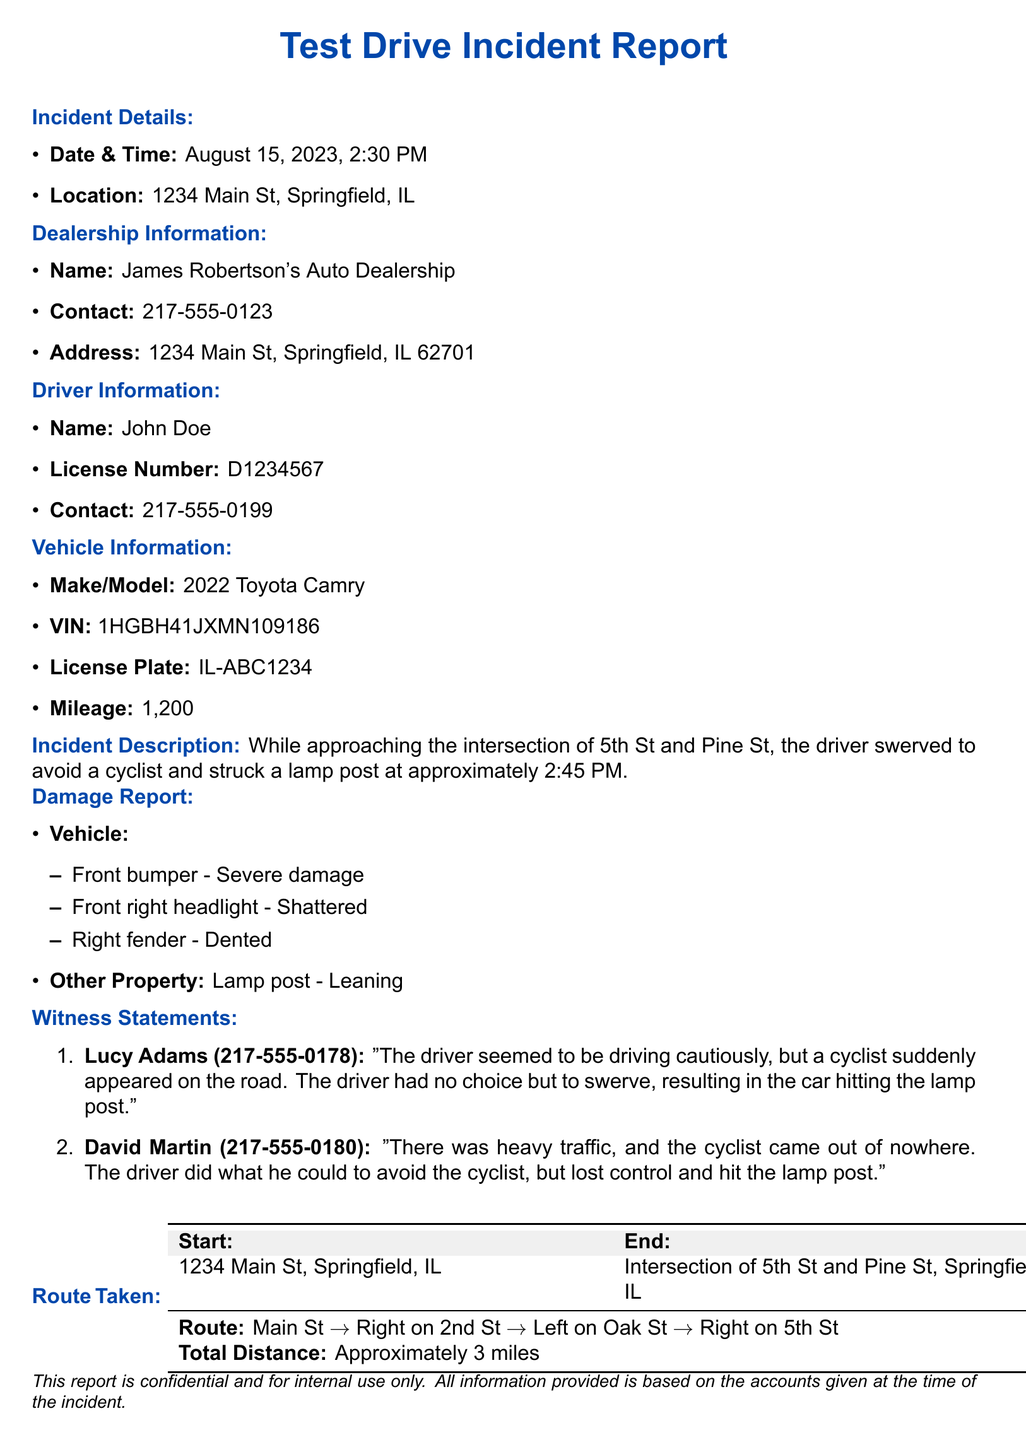What is the date and time of the incident? The date and time of the incident are explicitly stated in the document as August 15, 2023, 2:30 PM.
Answer: August 15, 2023, 2:30 PM What is the name of the dealership? The dealership's name is provided in the section for dealership information.
Answer: James Robertson's Auto Dealership Who was the driver of the vehicle? The document identifies the driver in the driver information section.
Answer: John Doe What was the make and model of the vehicle? The vehicle's make and model are specified in the vehicle information section.
Answer: 2022 Toyota Camry What damage occurred to the vehicle? The document lists the specific damages to the vehicle under the damage report section.
Answer: Front bumper - Severe damage, Front right headlight - Shattered, Right fender - Dented What did witness Lucy Adams say happened during the incident? Lucy Adams's statement is quoted in the witness statements section, reflecting her account of the incident.
Answer: "The driver seemed to be driving cautiously, but a cyclist suddenly appeared on the road. The driver had no choice but to swerve, resulting in the car hitting the lamp post." What was the total distance of the route taken? The total distance is provided in the route taken section of the document.
Answer: Approximately 3 miles What type of damage was reported for the lamp post? The damage to the lamp post is noted in the damage report section.
Answer: Leaning At what intersection did the incident occur? The intersection where the incident took place is mentioned directly in the incident description.
Answer: Intersection of 5th St and Pine St 